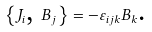<formula> <loc_0><loc_0><loc_500><loc_500>\left \{ J _ { i } \text {, } B _ { j } \right \} = - \varepsilon _ { i j k } B _ { k } \text {.}</formula> 